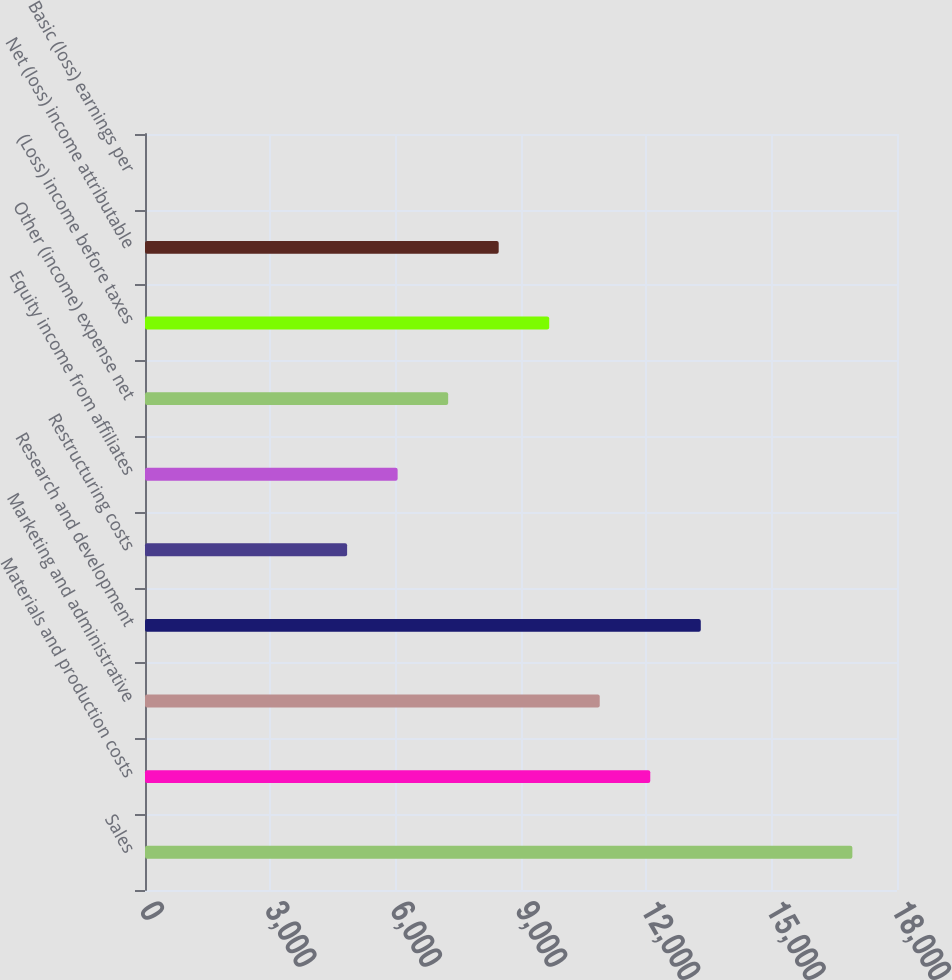Convert chart. <chart><loc_0><loc_0><loc_500><loc_500><bar_chart><fcel>Sales<fcel>Materials and production costs<fcel>Marketing and administrative<fcel>Research and development<fcel>Restructuring costs<fcel>Equity income from affiliates<fcel>Other (income) expense net<fcel>(Loss) income before taxes<fcel>Net (loss) income attributable<fcel>Basic (loss) earnings per<nl><fcel>16931.5<fcel>12094<fcel>10884.6<fcel>13303.4<fcel>4837.69<fcel>6047.07<fcel>7256.45<fcel>9675.21<fcel>8465.83<fcel>0.17<nl></chart> 